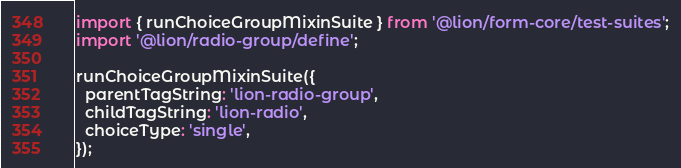<code> <loc_0><loc_0><loc_500><loc_500><_JavaScript_>import { runChoiceGroupMixinSuite } from '@lion/form-core/test-suites';
import '@lion/radio-group/define';

runChoiceGroupMixinSuite({
  parentTagString: 'lion-radio-group',
  childTagString: 'lion-radio',
  choiceType: 'single',
});
</code> 